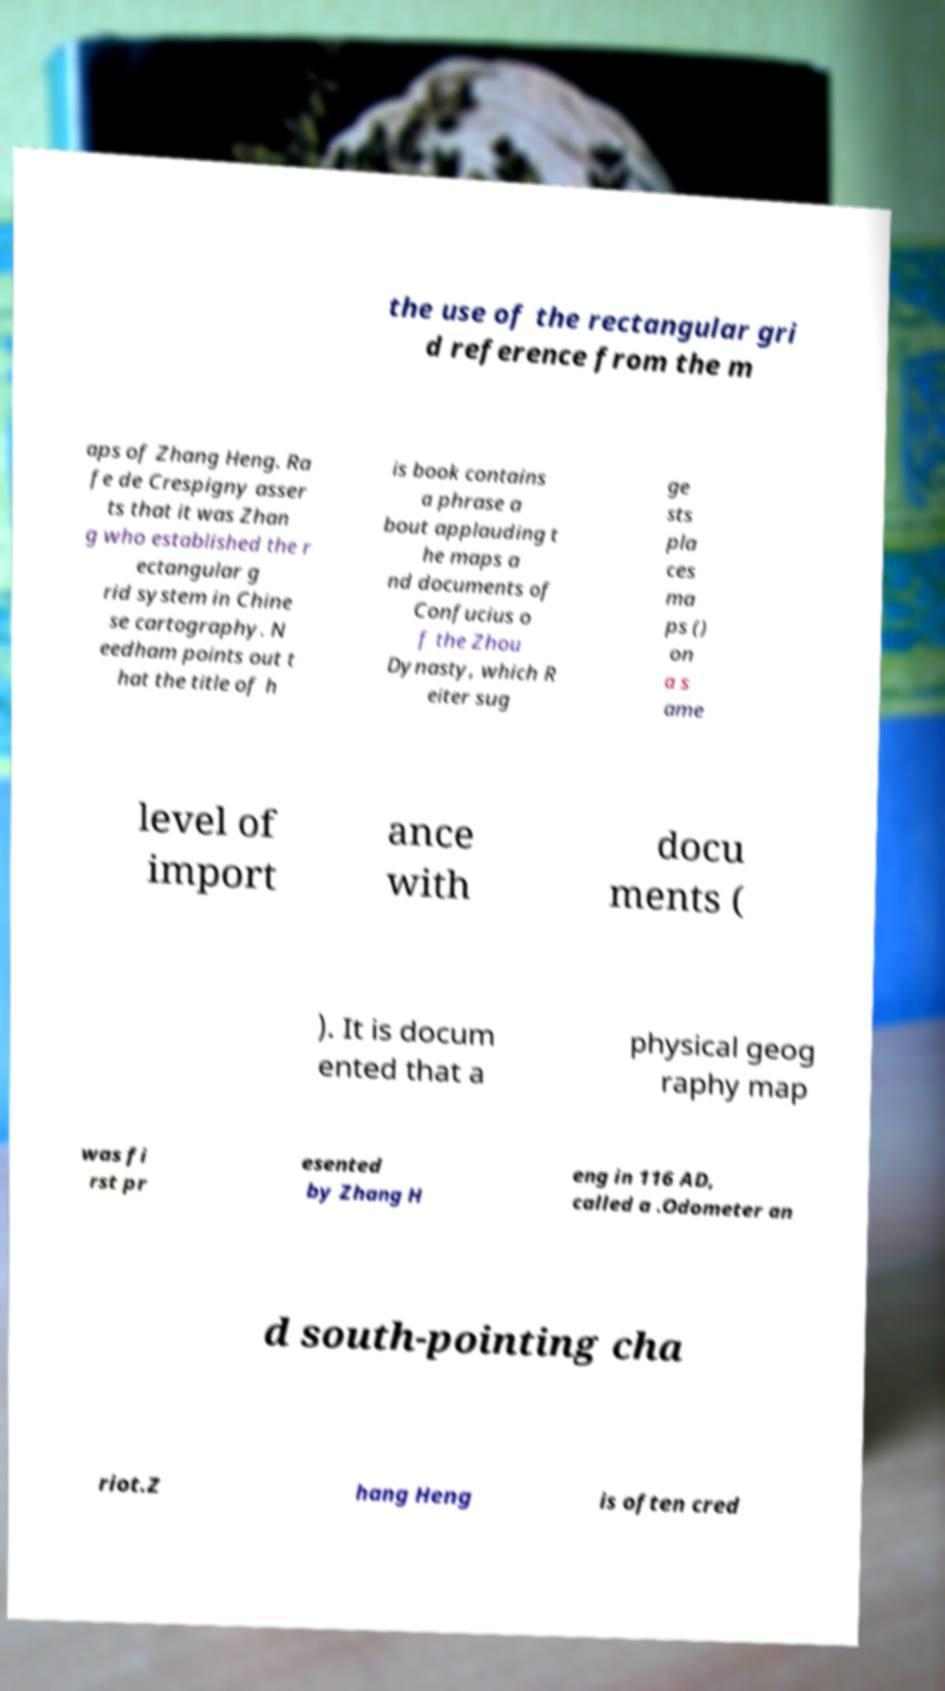What messages or text are displayed in this image? I need them in a readable, typed format. the use of the rectangular gri d reference from the m aps of Zhang Heng. Ra fe de Crespigny asser ts that it was Zhan g who established the r ectangular g rid system in Chine se cartography. N eedham points out t hat the title of h is book contains a phrase a bout applauding t he maps a nd documents of Confucius o f the Zhou Dynasty, which R eiter sug ge sts pla ces ma ps () on a s ame level of import ance with docu ments ( ). It is docum ented that a physical geog raphy map was fi rst pr esented by Zhang H eng in 116 AD, called a .Odometer an d south-pointing cha riot.Z hang Heng is often cred 